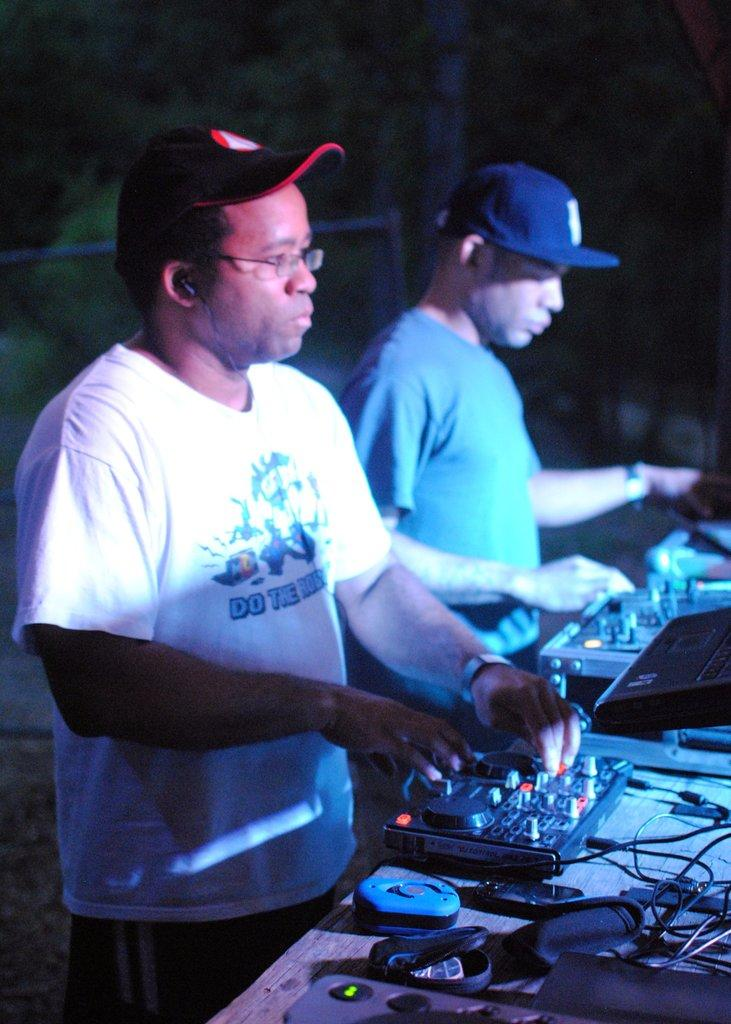How many people are in the image? There are two men in the image. What are the men doing in the image? The men are playing the role of a DJ. What type of clothing are the men wearing? The men are wearing T-shirts and caps. Can you describe the background of the image? The background of the image contains objects that are not clear. What type of tooth is visible in the image? There is no tooth present in the image. Can you tell me how many chickens are in the image? There are no chickens present in the image. 